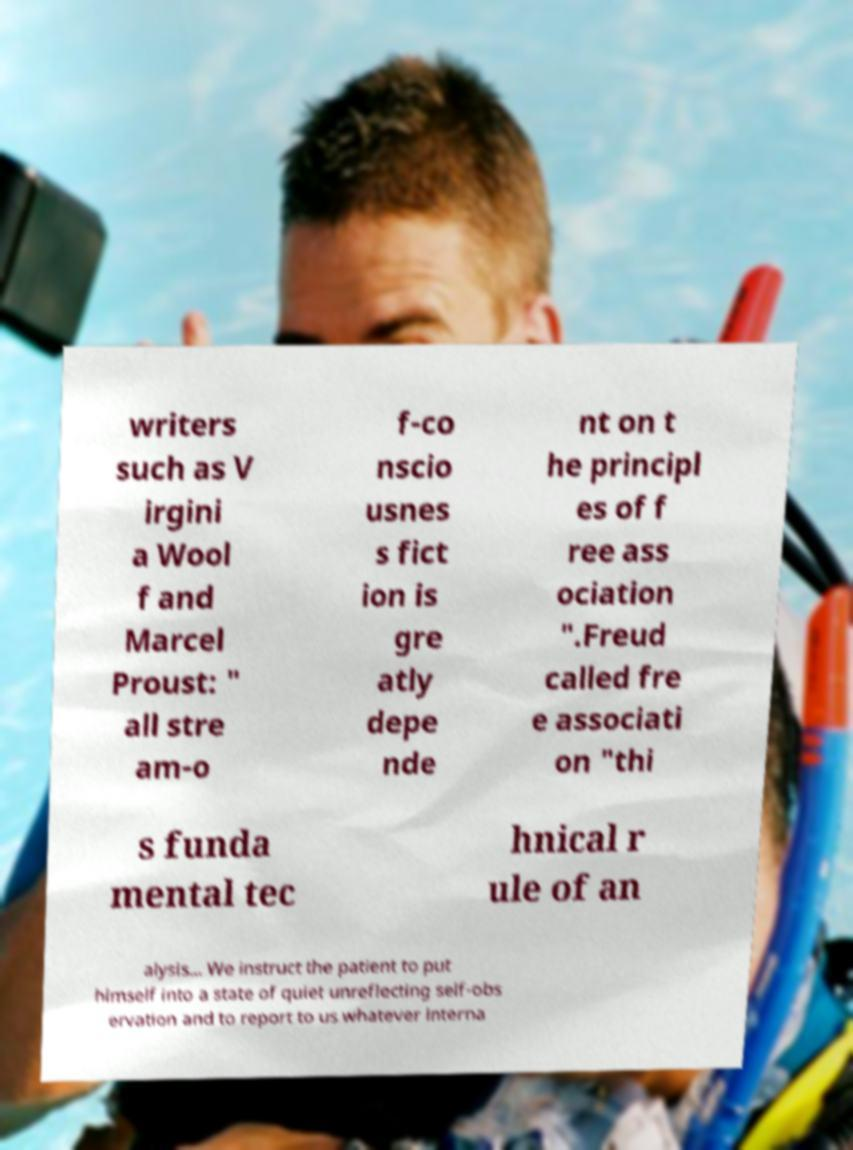Could you extract and type out the text from this image? writers such as V irgini a Wool f and Marcel Proust: " all stre am-o f-co nscio usnes s fict ion is gre atly depe nde nt on t he principl es of f ree ass ociation ".Freud called fre e associati on "thi s funda mental tec hnical r ule of an alysis... We instruct the patient to put himself into a state of quiet unreflecting self-obs ervation and to report to us whatever interna 